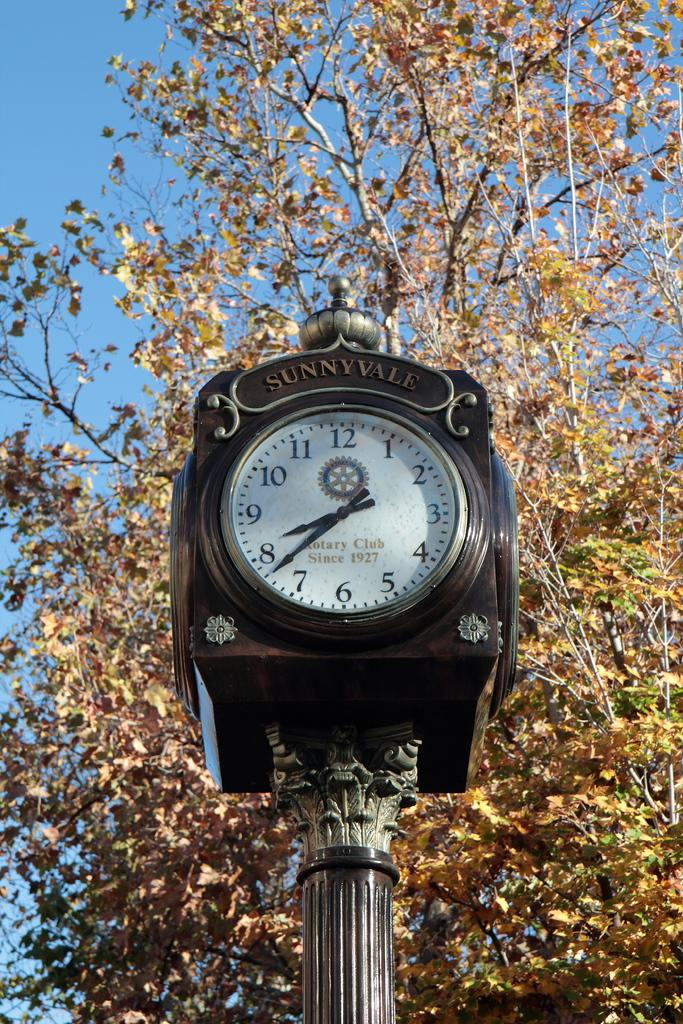<image>
Relay a brief, clear account of the picture shown. A clock showing the time as 8:43 with the Rotary club imprinted on the face and the name of the town Sunnyvale written above it. 